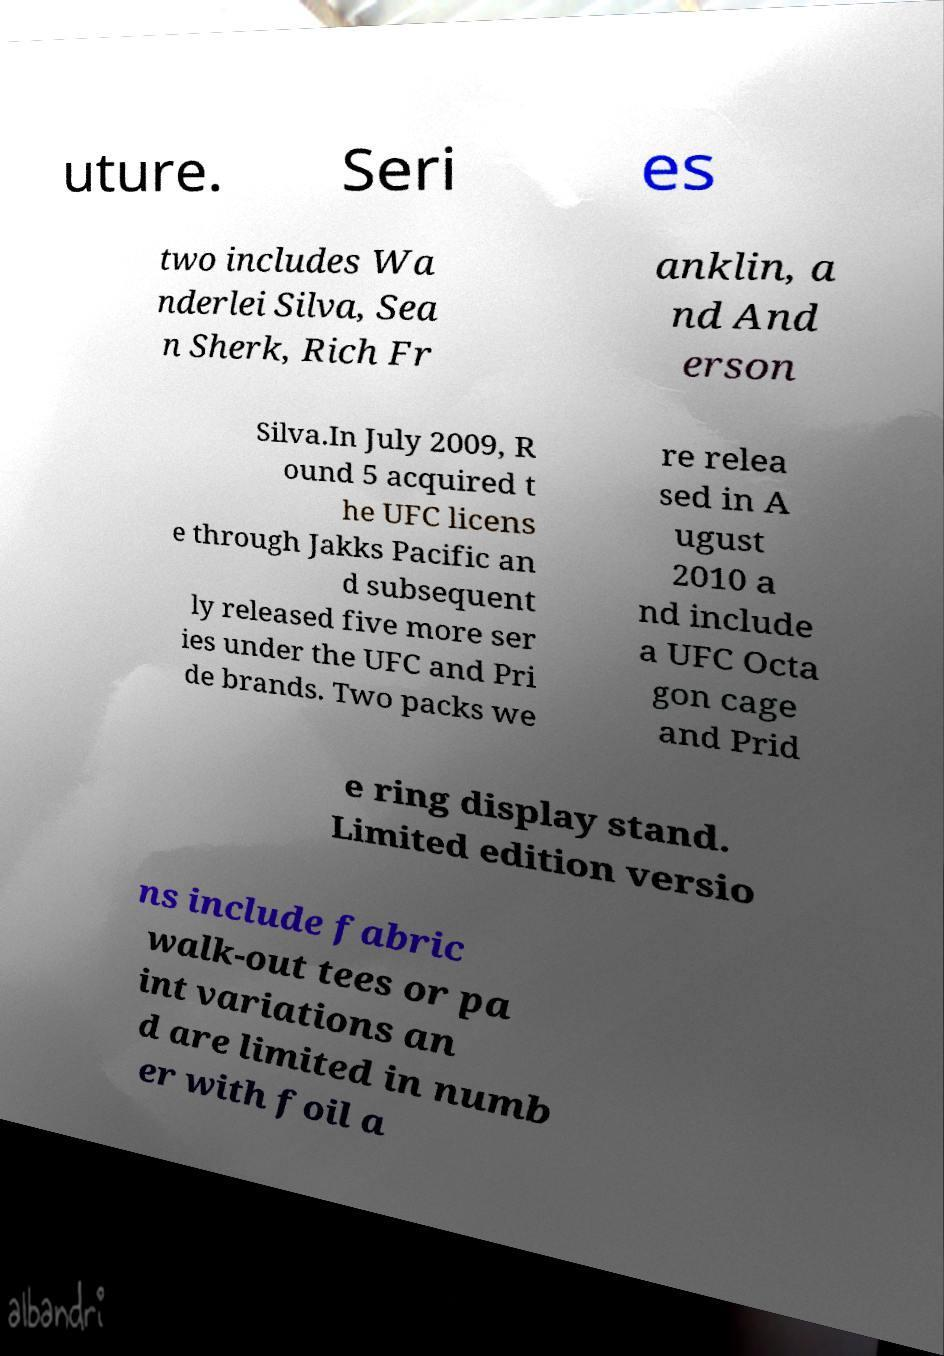Please read and relay the text visible in this image. What does it say? uture. Seri es two includes Wa nderlei Silva, Sea n Sherk, Rich Fr anklin, a nd And erson Silva.In July 2009, R ound 5 acquired t he UFC licens e through Jakks Pacific an d subsequent ly released five more ser ies under the UFC and Pri de brands. Two packs we re relea sed in A ugust 2010 a nd include a UFC Octa gon cage and Prid e ring display stand. Limited edition versio ns include fabric walk-out tees or pa int variations an d are limited in numb er with foil a 